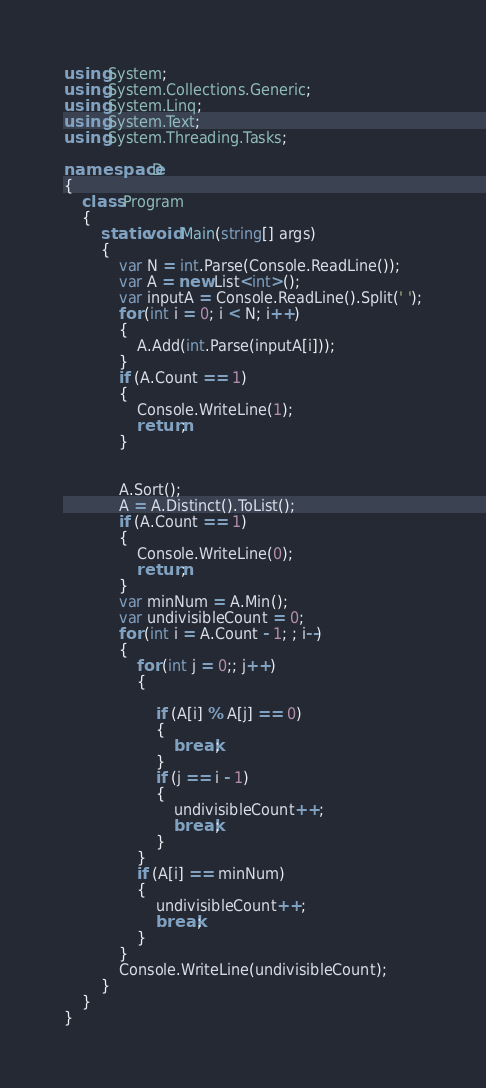<code> <loc_0><loc_0><loc_500><loc_500><_C#_>using System;
using System.Collections.Generic;
using System.Linq;
using System.Text;
using System.Threading.Tasks;

namespace D
{
    class Program
    {
        static void Main(string[] args)
        {
            var N = int.Parse(Console.ReadLine());
            var A = new List<int>();
            var inputA = Console.ReadLine().Split(' ');
            for (int i = 0; i < N; i++)
            {
                A.Add(int.Parse(inputA[i]));
            }
            if (A.Count == 1)
            {
                Console.WriteLine(1);
                return;
            }


            A.Sort();
            A = A.Distinct().ToList();
            if (A.Count == 1)
            {
                Console.WriteLine(0);
                return;
            }
            var minNum = A.Min();
            var undivisibleCount = 0;
            for (int i = A.Count - 1; ; i--)
            {
                for (int j = 0;; j++)
                {

                    if (A[i] % A[j] == 0)
                    {
                        break;
                    }
                    if (j == i - 1)
                    {
                        undivisibleCount++;
                        break;
                    }
                }
                if (A[i] == minNum)
                {
                    undivisibleCount++;
                    break;
                }
            }
            Console.WriteLine(undivisibleCount);
        }
    }
}
</code> 